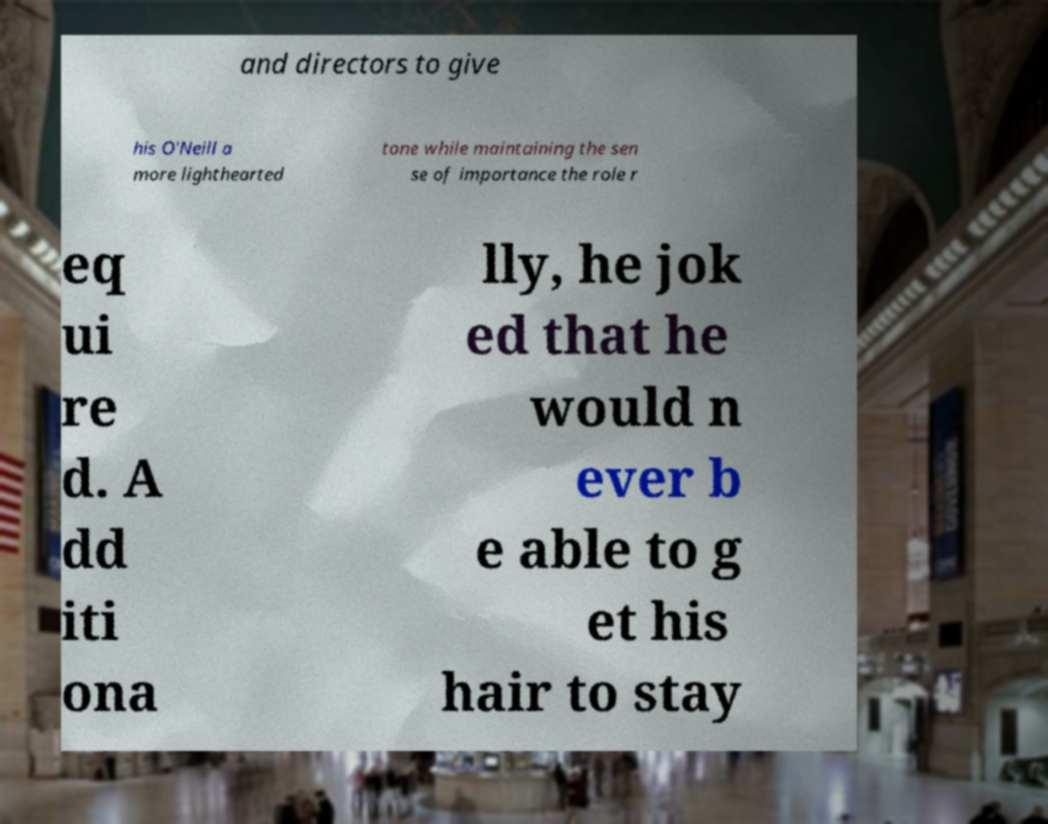Can you read and provide the text displayed in the image?This photo seems to have some interesting text. Can you extract and type it out for me? and directors to give his O'Neill a more lighthearted tone while maintaining the sen se of importance the role r eq ui re d. A dd iti ona lly, he jok ed that he would n ever b e able to g et his hair to stay 